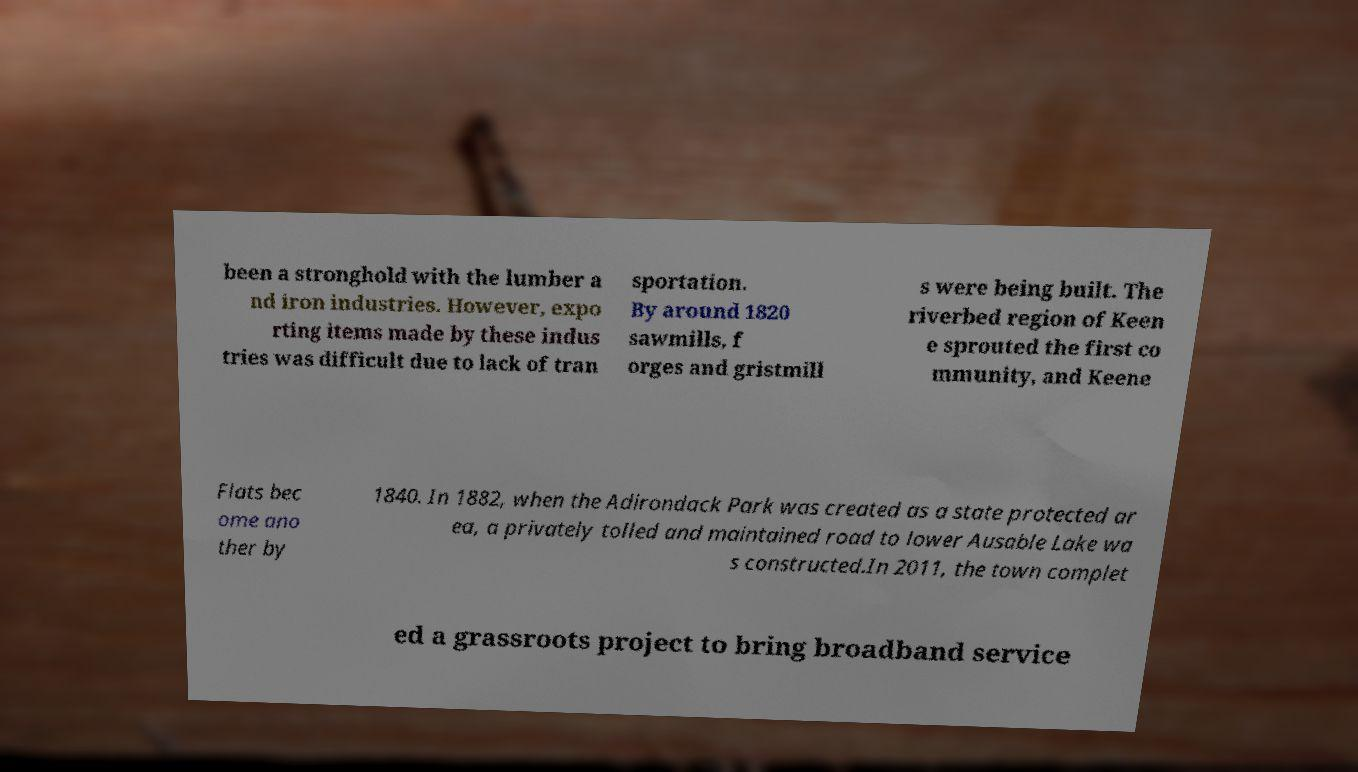There's text embedded in this image that I need extracted. Can you transcribe it verbatim? been a stronghold with the lumber a nd iron industries. However, expo rting items made by these indus tries was difficult due to lack of tran sportation. By around 1820 sawmills, f orges and gristmill s were being built. The riverbed region of Keen e sprouted the first co mmunity, and Keene Flats bec ome ano ther by 1840. In 1882, when the Adirondack Park was created as a state protected ar ea, a privately tolled and maintained road to lower Ausable Lake wa s constructed.In 2011, the town complet ed a grassroots project to bring broadband service 